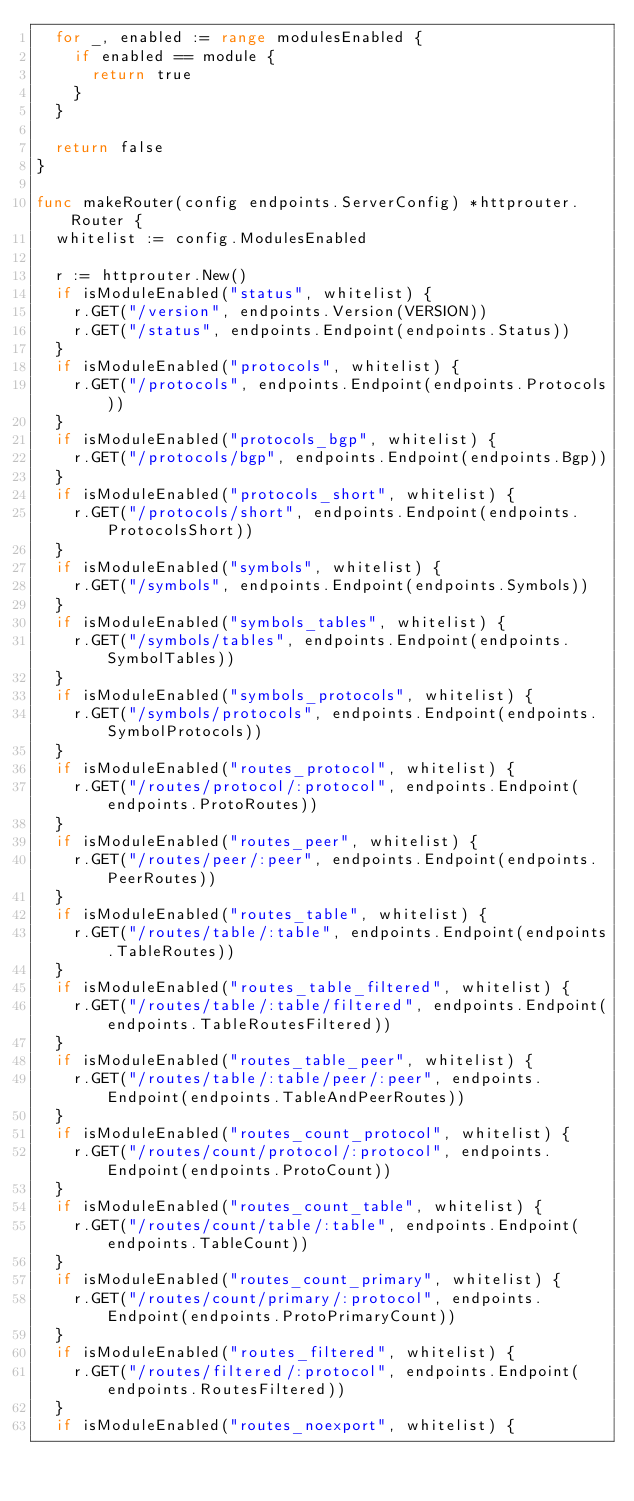Convert code to text. <code><loc_0><loc_0><loc_500><loc_500><_Go_>	for _, enabled := range modulesEnabled {
		if enabled == module {
			return true
		}
	}

	return false
}

func makeRouter(config endpoints.ServerConfig) *httprouter.Router {
	whitelist := config.ModulesEnabled

	r := httprouter.New()
	if isModuleEnabled("status", whitelist) {
		r.GET("/version", endpoints.Version(VERSION))
		r.GET("/status", endpoints.Endpoint(endpoints.Status))
	}
	if isModuleEnabled("protocols", whitelist) {
		r.GET("/protocols", endpoints.Endpoint(endpoints.Protocols))
	}
	if isModuleEnabled("protocols_bgp", whitelist) {
		r.GET("/protocols/bgp", endpoints.Endpoint(endpoints.Bgp))
	}
	if isModuleEnabled("protocols_short", whitelist) {
		r.GET("/protocols/short", endpoints.Endpoint(endpoints.ProtocolsShort))
	}
	if isModuleEnabled("symbols", whitelist) {
		r.GET("/symbols", endpoints.Endpoint(endpoints.Symbols))
	}
	if isModuleEnabled("symbols_tables", whitelist) {
		r.GET("/symbols/tables", endpoints.Endpoint(endpoints.SymbolTables))
	}
	if isModuleEnabled("symbols_protocols", whitelist) {
		r.GET("/symbols/protocols", endpoints.Endpoint(endpoints.SymbolProtocols))
	}
	if isModuleEnabled("routes_protocol", whitelist) {
		r.GET("/routes/protocol/:protocol", endpoints.Endpoint(endpoints.ProtoRoutes))
	}
	if isModuleEnabled("routes_peer", whitelist) {
		r.GET("/routes/peer/:peer", endpoints.Endpoint(endpoints.PeerRoutes))
	}
	if isModuleEnabled("routes_table", whitelist) {
		r.GET("/routes/table/:table", endpoints.Endpoint(endpoints.TableRoutes))
	}
	if isModuleEnabled("routes_table_filtered", whitelist) {
		r.GET("/routes/table/:table/filtered", endpoints.Endpoint(endpoints.TableRoutesFiltered))
	}
	if isModuleEnabled("routes_table_peer", whitelist) {
		r.GET("/routes/table/:table/peer/:peer", endpoints.Endpoint(endpoints.TableAndPeerRoutes))
	}
	if isModuleEnabled("routes_count_protocol", whitelist) {
		r.GET("/routes/count/protocol/:protocol", endpoints.Endpoint(endpoints.ProtoCount))
	}
	if isModuleEnabled("routes_count_table", whitelist) {
		r.GET("/routes/count/table/:table", endpoints.Endpoint(endpoints.TableCount))
	}
	if isModuleEnabled("routes_count_primary", whitelist) {
		r.GET("/routes/count/primary/:protocol", endpoints.Endpoint(endpoints.ProtoPrimaryCount))
	}
	if isModuleEnabled("routes_filtered", whitelist) {
		r.GET("/routes/filtered/:protocol", endpoints.Endpoint(endpoints.RoutesFiltered))
	}
	if isModuleEnabled("routes_noexport", whitelist) {</code> 